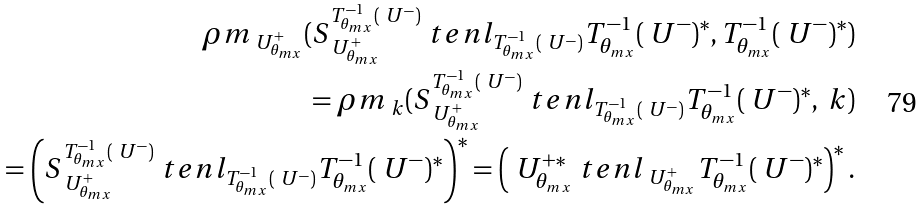<formula> <loc_0><loc_0><loc_500><loc_500>\rho m _ { \ U _ { \theta _ { m x } } ^ { + } } ( S _ { \ U _ { \theta _ { m x } } ^ { + } } ^ { T _ { \theta _ { m x } } ^ { - 1 } ( \ U ^ { - } ) } \ t e n l _ { T _ { \theta _ { m x } } ^ { - 1 } ( \ U ^ { - } ) } T _ { \theta _ { m x } } ^ { - 1 } ( \ U ^ { - } ) ^ { * } , T _ { \theta _ { m x } } ^ { - 1 } ( \ U ^ { - } ) ^ { * } ) \\ = \rho m _ { \ k } ( S _ { \ U _ { \theta _ { m x } } ^ { + } } ^ { T _ { \theta _ { m x } } ^ { - 1 } ( \ U ^ { - } ) } \ t e n l _ { T _ { \theta _ { m x } } ^ { - 1 } ( \ U ^ { - } ) } T _ { \theta _ { m x } } ^ { - 1 } ( \ U ^ { - } ) ^ { * } , \ k ) \\ = \left ( S _ { \ U _ { \theta _ { m x } } ^ { + } } ^ { T _ { \theta _ { m x } } ^ { - 1 } ( \ U ^ { - } ) } \ t e n l _ { T _ { \theta _ { m x } } ^ { - 1 } ( \ U ^ { - } ) } T _ { \theta _ { m x } } ^ { - 1 } ( \ U ^ { - } ) ^ { * } \right ) ^ { * } = \left ( \ U _ { \theta _ { m x } } ^ { + * } \ t e n l _ { \ U _ { \theta _ { m x } } ^ { + } } T _ { \theta _ { m x } } ^ { - 1 } ( \ U ^ { - } ) ^ { * } \right ) ^ { * } .</formula> 